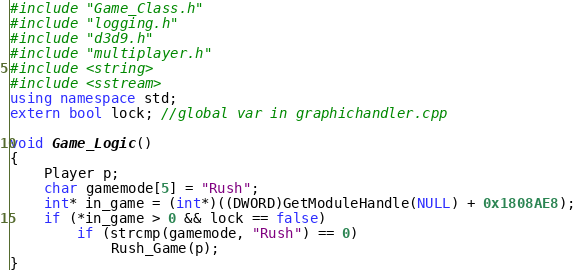<code> <loc_0><loc_0><loc_500><loc_500><_C++_>#include "Game_Class.h"
#include "logging.h"
#include "d3d9.h"
#include "multiplayer.h"
#include <string>
#include <sstream>
using namespace std;
extern bool lock; //global var in graphichandler.cpp

void Game_Logic()
{
	Player p;
	char gamemode[5] = "Rush";
	int* in_game = (int*)((DWORD)GetModuleHandle(NULL) + 0x1808AE8);
	if (*in_game > 0 && lock == false)
		if (strcmp(gamemode, "Rush") == 0)
			Rush_Game(p);
}</code> 